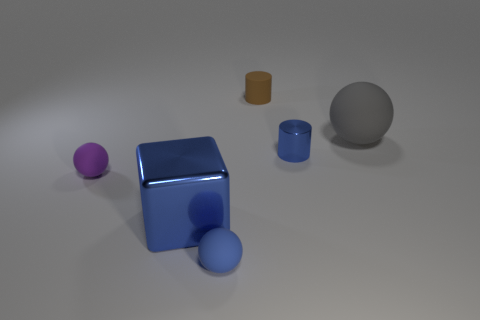Is there anything else that has the same material as the small blue cylinder?
Your answer should be compact. Yes. Is the material of the blue cylinder the same as the small blue thing that is on the left side of the brown cylinder?
Your answer should be very brief. No. There is a purple ball that is the same size as the brown rubber cylinder; what is its material?
Ensure brevity in your answer.  Rubber. Are there any purple spheres that have the same material as the large gray thing?
Offer a very short reply. Yes. There is a cylinder behind the tiny thing that is on the right side of the matte cylinder; is there a gray sphere in front of it?
Your answer should be very brief. Yes. What shape is the purple rubber thing that is the same size as the shiny cylinder?
Provide a succinct answer. Sphere. Is the size of the object that is behind the large sphere the same as the shiny thing to the left of the small brown cylinder?
Offer a terse response. No. How many spheres are there?
Your answer should be compact. 3. How big is the rubber ball to the right of the blue thing on the right side of the blue rubber object that is on the left side of the tiny shiny cylinder?
Your response must be concise. Large. Do the metal cylinder and the large cube have the same color?
Keep it short and to the point. Yes. 